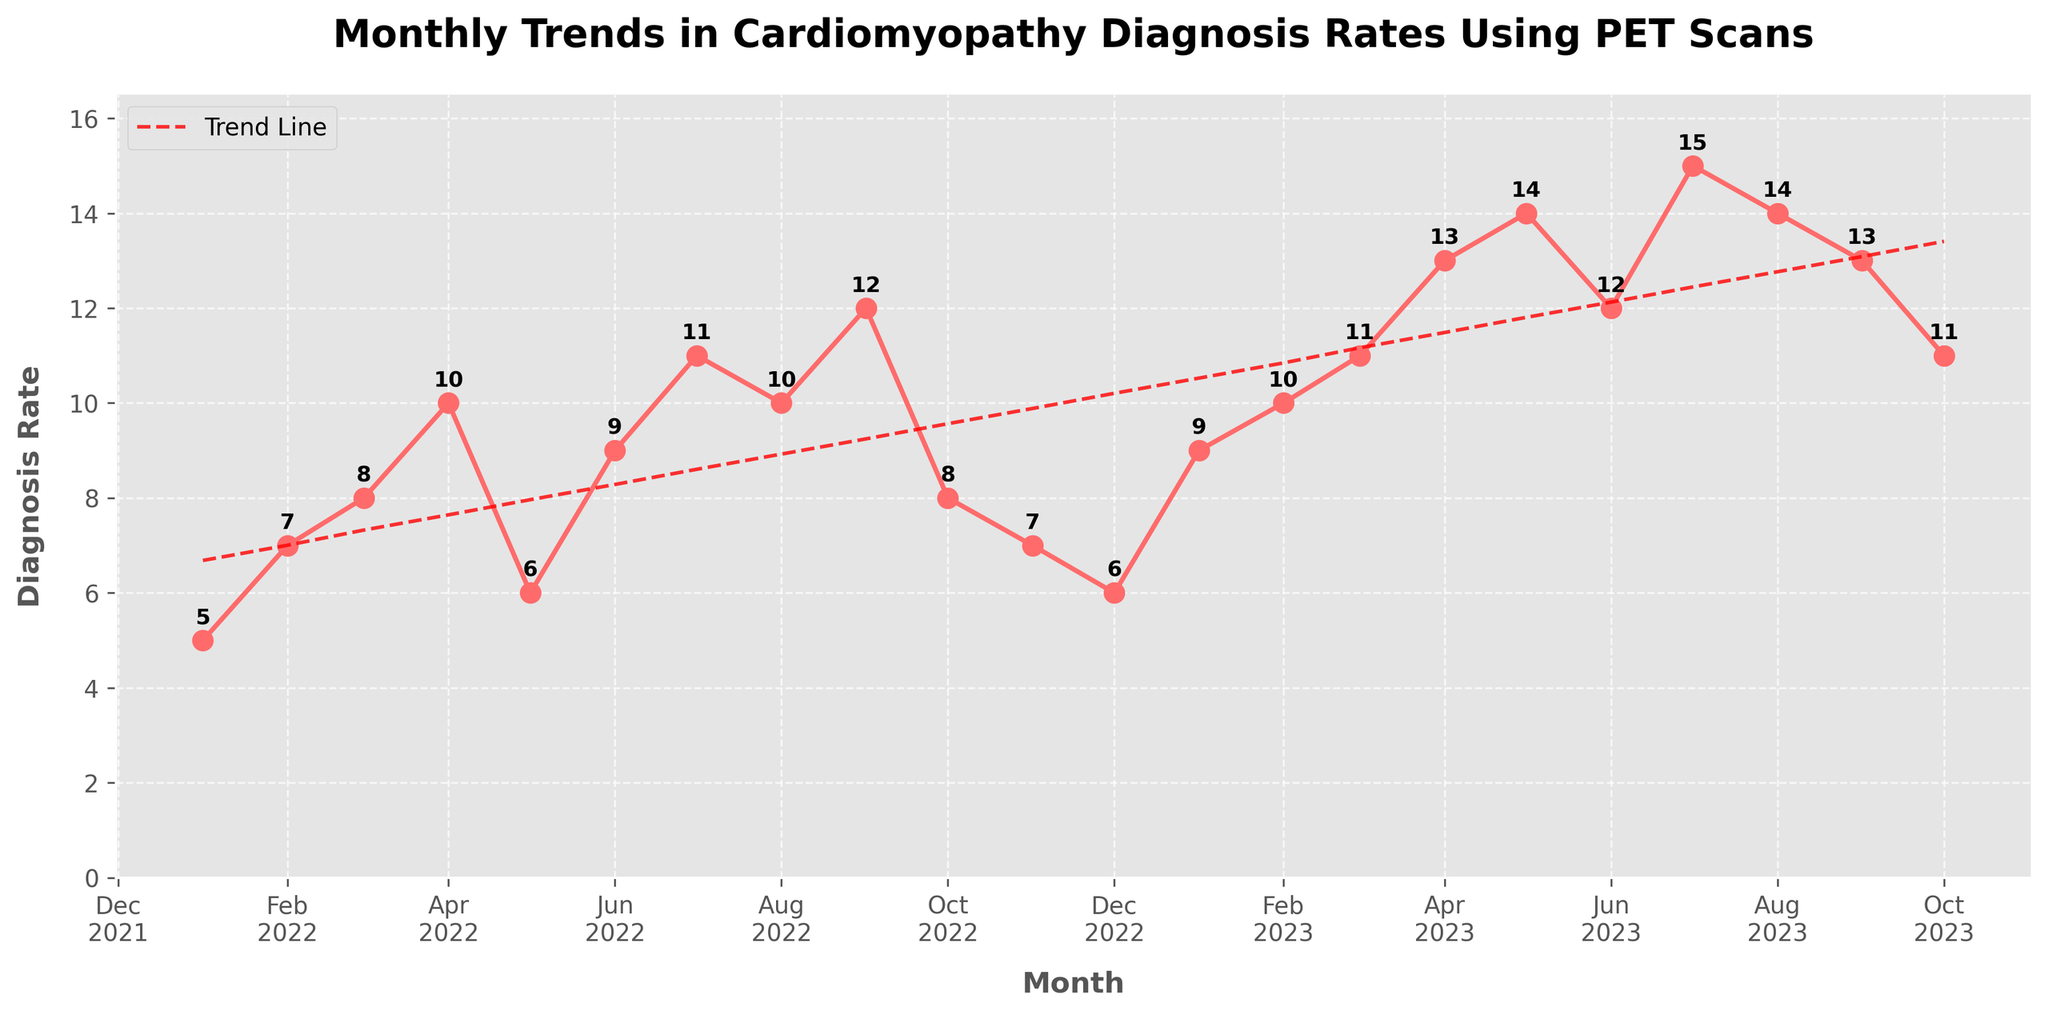What is the title of the plot? The title of the plot is prominently displayed at the top of the figure. It reads 'Monthly Trends in Cardiomyopathy Diagnosis Rates Using PET Scans'.
Answer: Monthly Trends in Cardiomyopathy Diagnosis Rates Using PET Scans Which month and year had the highest diagnosis rate? The plot shows each month's diagnosis rate, with September 2023 having the highest diagnosis rate, indicated as 15.
Answer: September 2023 What is the diagnosis rate for March 2022? Look at the data point for March 2022 along the time series. The diagnosis rate is labeled as 8.
Answer: 8 What is the range of diagnosis rates in the plot? The range is calculated by subtracting the lowest diagnosis rate from the highest. The highest rate is 15, and the lowest rate is 5, so the range is 15 - 5 = 10.
Answer: 10 How does the trend line behave over the months displayed? The trend line, a dashed red line, shows a positive trend, indicating an overall increase in the diagnosis rates over the given months.
Answer: Increasing What is the average diagnosis rate across all months in the figure? Sum all the diagnosis rates and divide by the number of months displayed. The sum of all rates from January 2022 to October 2023 is 204. There are 22 months in total, so the average is 204/22 ≈ 9.27.
Answer: 9.27 In which month of 2023 did the diagnosis rate first exceed 10? Starting from January 2023, the first diagnosis rate to exceed 10 is in March 2023, with a value of 11.
Answer: March 2023 Is the diagnosis rate in June 2022 higher or lower than in June 2023? Compare the rates for June in both years. June 2022 has a rate of 9, and June 2023 has a rate of 12, so June 2023 is higher.
Answer: Higher Which months experienced a decline in diagnosis rate from the previous month, and what were these months and rates? Observe the monthly data points. The months are May 2022 (10 to 6), October 2022 (12 to 8), November 2022 (8 to 7), and October 2023 (13 to 11).
Answer: May 2022, October 2022, November 2022, October 2023 What would you infer from the trend line combined with the individual data points about future diagnosis rates? The increasing trend line, along with generally rising individual data points, suggests that the diagnosis rates are likely to continue increasing if the current trend remains unchanged.
Answer: Expected to increase 